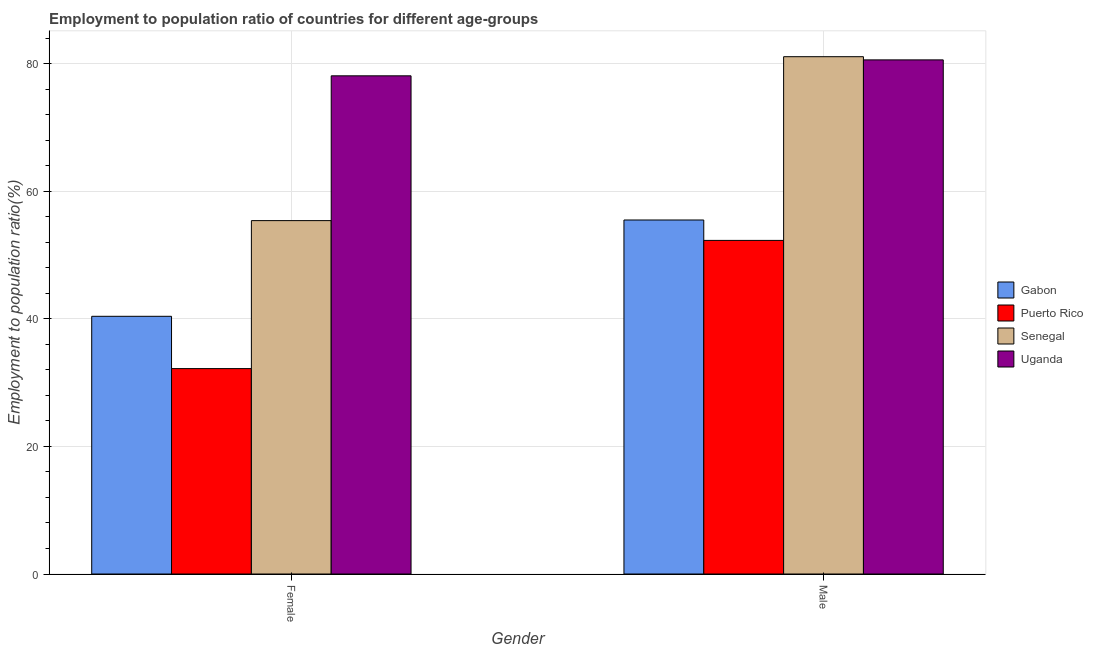How many different coloured bars are there?
Provide a short and direct response. 4. How many bars are there on the 2nd tick from the left?
Your answer should be compact. 4. How many bars are there on the 1st tick from the right?
Provide a succinct answer. 4. What is the employment to population ratio(female) in Gabon?
Give a very brief answer. 40.4. Across all countries, what is the maximum employment to population ratio(female)?
Your response must be concise. 78.1. Across all countries, what is the minimum employment to population ratio(male)?
Give a very brief answer. 52.3. In which country was the employment to population ratio(female) maximum?
Provide a short and direct response. Uganda. In which country was the employment to population ratio(female) minimum?
Your answer should be very brief. Puerto Rico. What is the total employment to population ratio(male) in the graph?
Your response must be concise. 269.5. What is the difference between the employment to population ratio(female) in Senegal and that in Gabon?
Provide a short and direct response. 15. What is the difference between the employment to population ratio(female) in Puerto Rico and the employment to population ratio(male) in Senegal?
Keep it short and to the point. -48.9. What is the average employment to population ratio(female) per country?
Offer a very short reply. 51.53. What is the difference between the employment to population ratio(male) and employment to population ratio(female) in Gabon?
Your response must be concise. 15.1. What is the ratio of the employment to population ratio(male) in Uganda to that in Gabon?
Provide a short and direct response. 1.45. Is the employment to population ratio(male) in Uganda less than that in Gabon?
Ensure brevity in your answer.  No. In how many countries, is the employment to population ratio(male) greater than the average employment to population ratio(male) taken over all countries?
Make the answer very short. 2. What does the 3rd bar from the left in Male represents?
Keep it short and to the point. Senegal. What does the 4th bar from the right in Female represents?
Give a very brief answer. Gabon. How many bars are there?
Your answer should be very brief. 8. Are all the bars in the graph horizontal?
Offer a very short reply. No. Are the values on the major ticks of Y-axis written in scientific E-notation?
Your answer should be compact. No. Does the graph contain grids?
Offer a terse response. Yes. Where does the legend appear in the graph?
Your answer should be compact. Center right. How many legend labels are there?
Your answer should be compact. 4. How are the legend labels stacked?
Provide a short and direct response. Vertical. What is the title of the graph?
Offer a very short reply. Employment to population ratio of countries for different age-groups. Does "Australia" appear as one of the legend labels in the graph?
Provide a succinct answer. No. What is the Employment to population ratio(%) of Gabon in Female?
Provide a succinct answer. 40.4. What is the Employment to population ratio(%) of Puerto Rico in Female?
Your answer should be compact. 32.2. What is the Employment to population ratio(%) of Senegal in Female?
Keep it short and to the point. 55.4. What is the Employment to population ratio(%) in Uganda in Female?
Provide a short and direct response. 78.1. What is the Employment to population ratio(%) in Gabon in Male?
Offer a very short reply. 55.5. What is the Employment to population ratio(%) of Puerto Rico in Male?
Offer a very short reply. 52.3. What is the Employment to population ratio(%) of Senegal in Male?
Keep it short and to the point. 81.1. What is the Employment to population ratio(%) of Uganda in Male?
Make the answer very short. 80.6. Across all Gender, what is the maximum Employment to population ratio(%) of Gabon?
Offer a very short reply. 55.5. Across all Gender, what is the maximum Employment to population ratio(%) of Puerto Rico?
Make the answer very short. 52.3. Across all Gender, what is the maximum Employment to population ratio(%) in Senegal?
Offer a terse response. 81.1. Across all Gender, what is the maximum Employment to population ratio(%) in Uganda?
Provide a short and direct response. 80.6. Across all Gender, what is the minimum Employment to population ratio(%) in Gabon?
Make the answer very short. 40.4. Across all Gender, what is the minimum Employment to population ratio(%) in Puerto Rico?
Make the answer very short. 32.2. Across all Gender, what is the minimum Employment to population ratio(%) in Senegal?
Your response must be concise. 55.4. Across all Gender, what is the minimum Employment to population ratio(%) of Uganda?
Offer a terse response. 78.1. What is the total Employment to population ratio(%) in Gabon in the graph?
Ensure brevity in your answer.  95.9. What is the total Employment to population ratio(%) in Puerto Rico in the graph?
Provide a succinct answer. 84.5. What is the total Employment to population ratio(%) in Senegal in the graph?
Give a very brief answer. 136.5. What is the total Employment to population ratio(%) in Uganda in the graph?
Give a very brief answer. 158.7. What is the difference between the Employment to population ratio(%) of Gabon in Female and that in Male?
Keep it short and to the point. -15.1. What is the difference between the Employment to population ratio(%) in Puerto Rico in Female and that in Male?
Your answer should be very brief. -20.1. What is the difference between the Employment to population ratio(%) of Senegal in Female and that in Male?
Your response must be concise. -25.7. What is the difference between the Employment to population ratio(%) of Uganda in Female and that in Male?
Your answer should be very brief. -2.5. What is the difference between the Employment to population ratio(%) of Gabon in Female and the Employment to population ratio(%) of Puerto Rico in Male?
Ensure brevity in your answer.  -11.9. What is the difference between the Employment to population ratio(%) in Gabon in Female and the Employment to population ratio(%) in Senegal in Male?
Make the answer very short. -40.7. What is the difference between the Employment to population ratio(%) in Gabon in Female and the Employment to population ratio(%) in Uganda in Male?
Your answer should be compact. -40.2. What is the difference between the Employment to population ratio(%) in Puerto Rico in Female and the Employment to population ratio(%) in Senegal in Male?
Give a very brief answer. -48.9. What is the difference between the Employment to population ratio(%) of Puerto Rico in Female and the Employment to population ratio(%) of Uganda in Male?
Offer a very short reply. -48.4. What is the difference between the Employment to population ratio(%) of Senegal in Female and the Employment to population ratio(%) of Uganda in Male?
Offer a very short reply. -25.2. What is the average Employment to population ratio(%) of Gabon per Gender?
Provide a succinct answer. 47.95. What is the average Employment to population ratio(%) of Puerto Rico per Gender?
Your answer should be compact. 42.25. What is the average Employment to population ratio(%) of Senegal per Gender?
Ensure brevity in your answer.  68.25. What is the average Employment to population ratio(%) in Uganda per Gender?
Offer a terse response. 79.35. What is the difference between the Employment to population ratio(%) in Gabon and Employment to population ratio(%) in Puerto Rico in Female?
Offer a very short reply. 8.2. What is the difference between the Employment to population ratio(%) in Gabon and Employment to population ratio(%) in Uganda in Female?
Keep it short and to the point. -37.7. What is the difference between the Employment to population ratio(%) in Puerto Rico and Employment to population ratio(%) in Senegal in Female?
Provide a short and direct response. -23.2. What is the difference between the Employment to population ratio(%) in Puerto Rico and Employment to population ratio(%) in Uganda in Female?
Provide a succinct answer. -45.9. What is the difference between the Employment to population ratio(%) in Senegal and Employment to population ratio(%) in Uganda in Female?
Provide a succinct answer. -22.7. What is the difference between the Employment to population ratio(%) in Gabon and Employment to population ratio(%) in Senegal in Male?
Offer a very short reply. -25.6. What is the difference between the Employment to population ratio(%) in Gabon and Employment to population ratio(%) in Uganda in Male?
Make the answer very short. -25.1. What is the difference between the Employment to population ratio(%) in Puerto Rico and Employment to population ratio(%) in Senegal in Male?
Your response must be concise. -28.8. What is the difference between the Employment to population ratio(%) in Puerto Rico and Employment to population ratio(%) in Uganda in Male?
Provide a short and direct response. -28.3. What is the ratio of the Employment to population ratio(%) in Gabon in Female to that in Male?
Offer a very short reply. 0.73. What is the ratio of the Employment to population ratio(%) of Puerto Rico in Female to that in Male?
Give a very brief answer. 0.62. What is the ratio of the Employment to population ratio(%) in Senegal in Female to that in Male?
Keep it short and to the point. 0.68. What is the difference between the highest and the second highest Employment to population ratio(%) in Puerto Rico?
Ensure brevity in your answer.  20.1. What is the difference between the highest and the second highest Employment to population ratio(%) of Senegal?
Provide a succinct answer. 25.7. What is the difference between the highest and the second highest Employment to population ratio(%) of Uganda?
Give a very brief answer. 2.5. What is the difference between the highest and the lowest Employment to population ratio(%) of Puerto Rico?
Your answer should be very brief. 20.1. What is the difference between the highest and the lowest Employment to population ratio(%) of Senegal?
Provide a short and direct response. 25.7. 